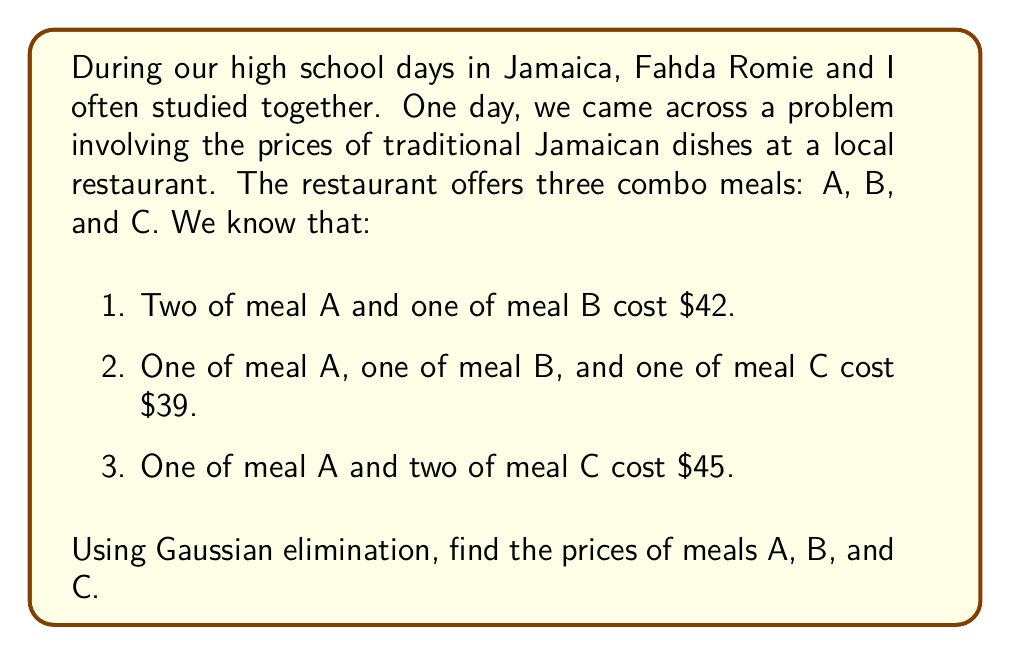Help me with this question. Let's solve this problem using Gaussian elimination. We'll start by setting up the system of linear equations:

1. Let $x$ be the price of meal A, $y$ be the price of meal B, and $z$ be the price of meal C.
2. We can represent the given information as a system of linear equations:

$$
\begin{aligned}
2x + y &= 42 \\
x + y + z &= 39 \\
x + 2z &= 45
\end{aligned}
$$

3. Now, let's write this as an augmented matrix:

$$
\begin{bmatrix}
2 & 1 & 0 & 42 \\
1 & 1 & 1 & 39 \\
1 & 0 & 2 & 45
\end{bmatrix}
$$

4. We'll use Gaussian elimination to transform this into row echelon form:

Step 1: Subtract row 2 from row 1
$$
\begin{bmatrix}
1 & 0 & -1 & 3 \\
1 & 1 & 1 & 39 \\
1 & 0 & 2 & 45
\end{bmatrix}
$$

Step 2: Subtract row 1 from row 3
$$
\begin{bmatrix}
1 & 0 & -1 & 3 \\
1 & 1 & 1 & 39 \\
0 & 0 & 3 & 42
\end{bmatrix}
$$

Step 3: Subtract row 1 from row 2
$$
\begin{bmatrix}
1 & 0 & -1 & 3 \\
0 & 1 & 2 & 36 \\
0 & 0 & 3 & 42
\end{bmatrix}
$$

5. Now we have the matrix in row echelon form. We can solve for $z$, then $y$, and finally $x$:

From row 3: $3z = 42$, so $z = 14$

From row 2: $y + 2(14) = 36$, so $y = 8$

From row 1: $x - 14 = 3$, so $x = 17$

Therefore, meal A costs $17, meal B costs $8, and meal C costs $14.
Answer: Meal A: $17
Meal B: $8
Meal C: $14 